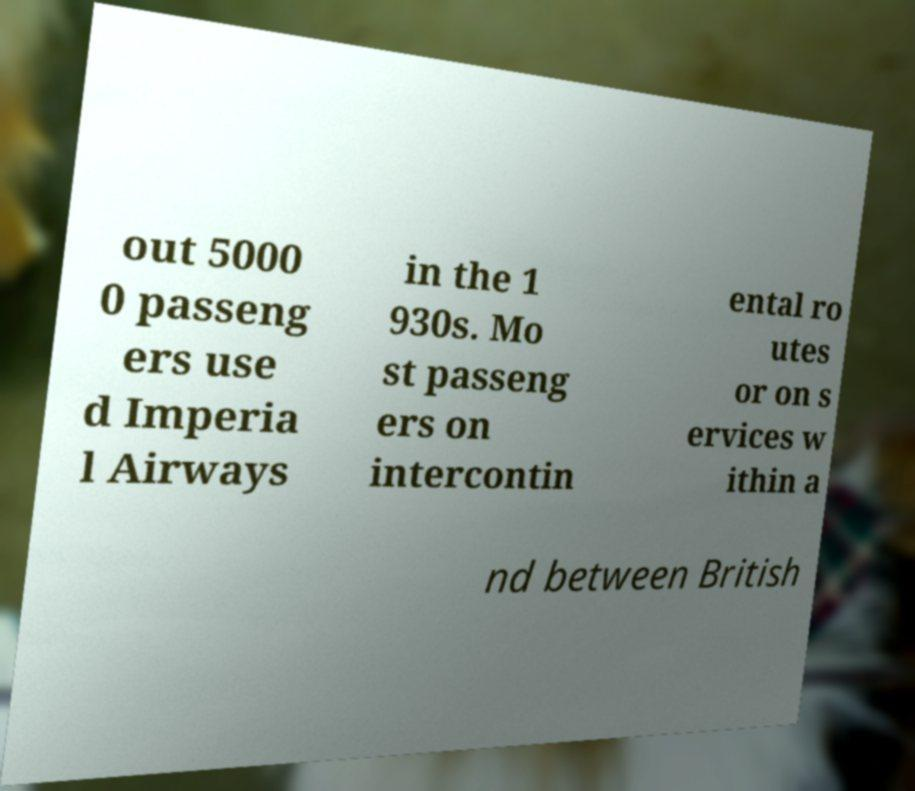Please read and relay the text visible in this image. What does it say? out 5000 0 passeng ers use d Imperia l Airways in the 1 930s. Mo st passeng ers on intercontin ental ro utes or on s ervices w ithin a nd between British 